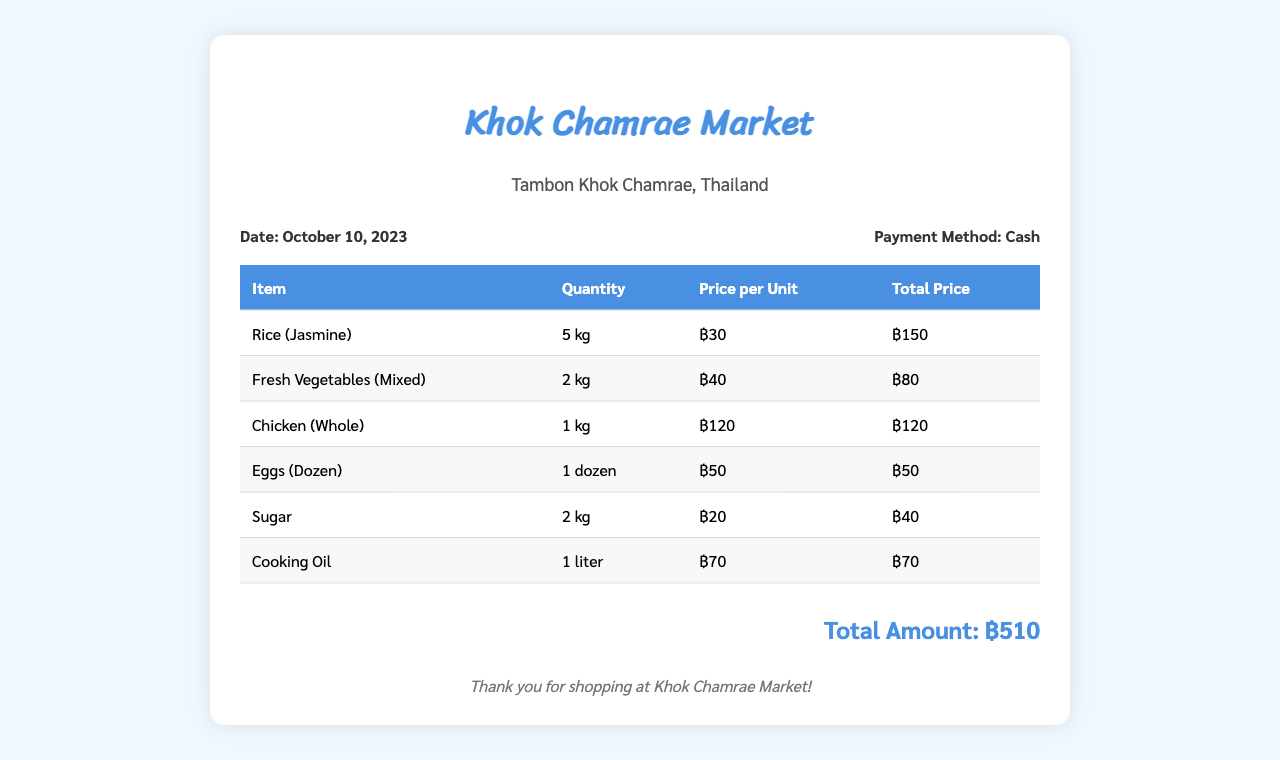What is the date of the invoice? The invoice date is explicitly stated in the document accompanying the purchase details.
Answer: October 10, 2023 What is the total amount spent? The total amount is calculated at the bottom of the invoice, summarizing all the item prices.
Answer: ฿510 How much did the rice cost per kg? The price per unit for rice is provided in the table of items purchased.
Answer: ฿30 What quantity of eggs was purchased? The quantity of eggs is listed in the itemized table under their respective row.
Answer: 1 dozen How much was spent on sugar? The total price for sugar is shown alongside its quantity and unit price in the invoice.
Answer: ฿40 What payment method was used? The method of payment is clearly indicated in the invoice details section.
Answer: Cash Which item had the highest unit price? By comparing the prices listed for each item, the highest unit price can be determined.
Answer: Chicken (Whole) What is the price of cooking oil per liter? The price for cooking oil is specified in the table with the item details.
Answer: ฿70 How many kilograms of fresh vegetables were purchased? The quantity of fresh vegetables is stated in the itemized list in the invoice.
Answer: 2 kg 